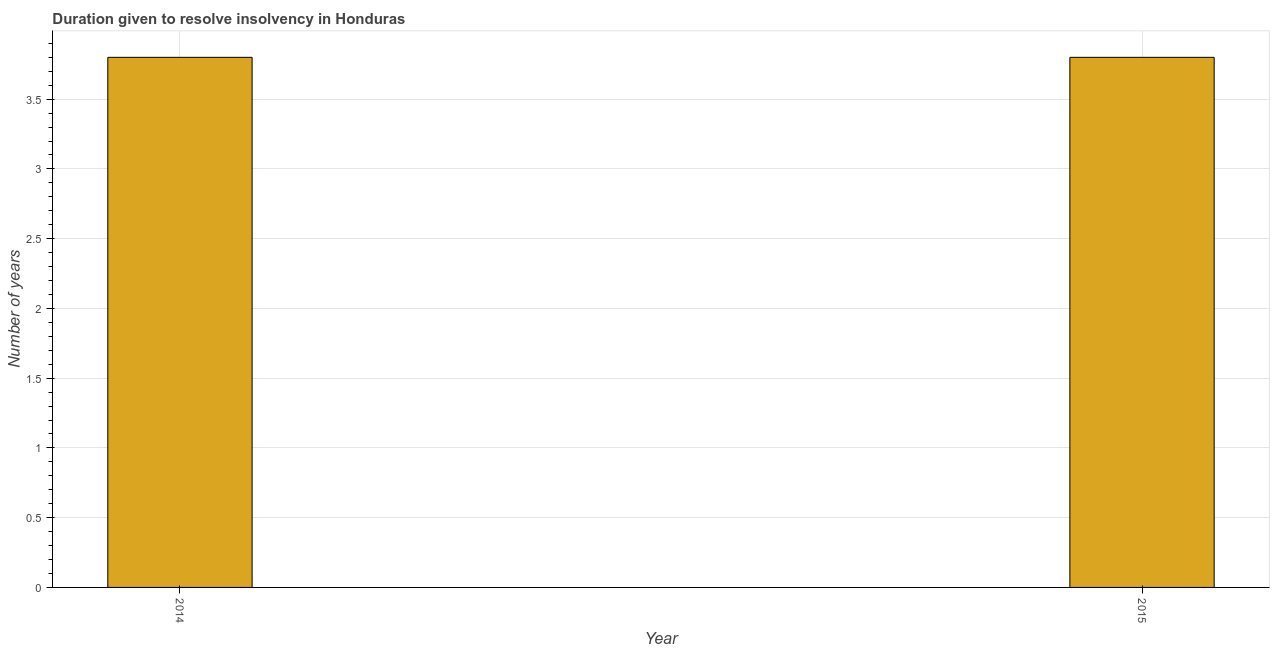Does the graph contain any zero values?
Your response must be concise. No. What is the title of the graph?
Your answer should be compact. Duration given to resolve insolvency in Honduras. What is the label or title of the X-axis?
Make the answer very short. Year. What is the label or title of the Y-axis?
Give a very brief answer. Number of years. What is the number of years to resolve insolvency in 2015?
Give a very brief answer. 3.8. Across all years, what is the minimum number of years to resolve insolvency?
Your response must be concise. 3.8. In which year was the number of years to resolve insolvency maximum?
Provide a short and direct response. 2014. What is the sum of the number of years to resolve insolvency?
Give a very brief answer. 7.6. In how many years, is the number of years to resolve insolvency greater than 0.9 ?
Offer a very short reply. 2. Is the number of years to resolve insolvency in 2014 less than that in 2015?
Give a very brief answer. No. How many bars are there?
Give a very brief answer. 2. Are all the bars in the graph horizontal?
Keep it short and to the point. No. How many years are there in the graph?
Offer a terse response. 2. What is the Number of years of 2015?
Make the answer very short. 3.8. What is the difference between the Number of years in 2014 and 2015?
Offer a very short reply. 0. What is the ratio of the Number of years in 2014 to that in 2015?
Your response must be concise. 1. 